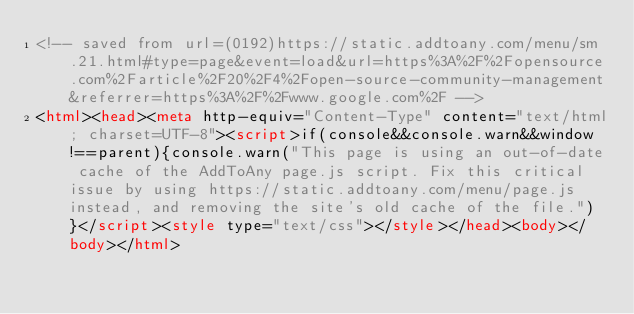Convert code to text. <code><loc_0><loc_0><loc_500><loc_500><_HTML_><!-- saved from url=(0192)https://static.addtoany.com/menu/sm.21.html#type=page&event=load&url=https%3A%2F%2Fopensource.com%2Farticle%2F20%2F4%2Fopen-source-community-management&referrer=https%3A%2F%2Fwww.google.com%2F -->
<html><head><meta http-equiv="Content-Type" content="text/html; charset=UTF-8"><script>if(console&&console.warn&&window!==parent){console.warn("This page is using an out-of-date cache of the AddToAny page.js script. Fix this critical issue by using https://static.addtoany.com/menu/page.js instead, and removing the site's old cache of the file.")}</script><style type="text/css"></style></head><body></body></html></code> 